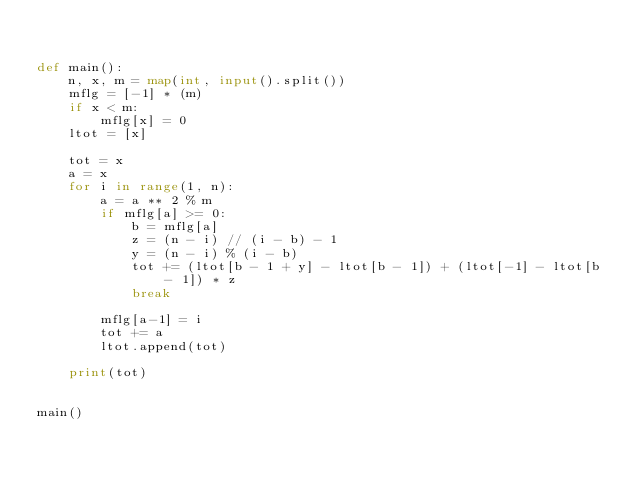<code> <loc_0><loc_0><loc_500><loc_500><_Python_>

def main():
    n, x, m = map(int, input().split())
    mflg = [-1] * (m)
    if x < m:
        mflg[x] = 0
    ltot = [x]

    tot = x
    a = x
    for i in range(1, n):
        a = a ** 2 % m
        if mflg[a] >= 0:
            b = mflg[a]
            z = (n - i) // (i - b) - 1
            y = (n - i) % (i - b)
            tot += (ltot[b - 1 + y] - ltot[b - 1]) + (ltot[-1] - ltot[b - 1]) * z
            break

        mflg[a-1] = i
        tot += a
        ltot.append(tot)

    print(tot)


main()

</code> 